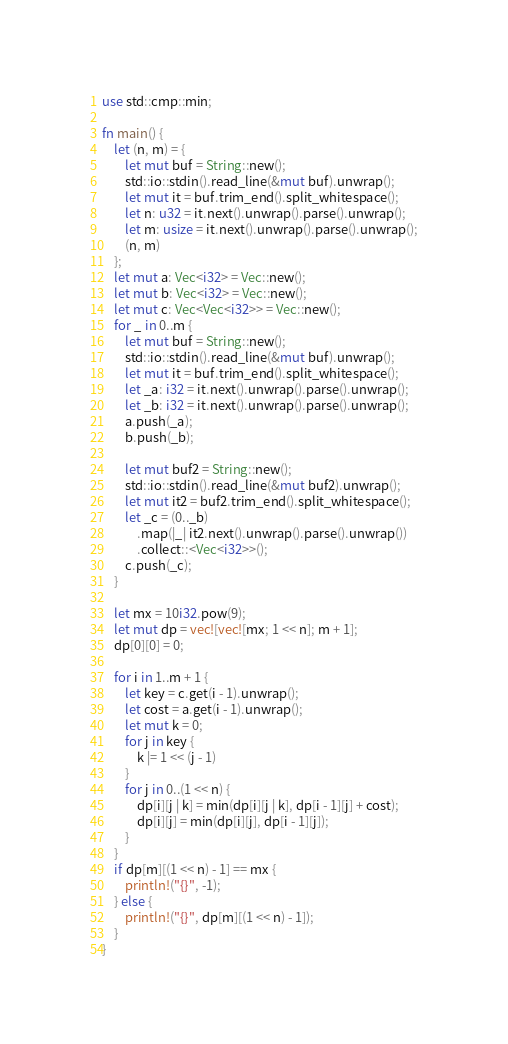Convert code to text. <code><loc_0><loc_0><loc_500><loc_500><_Rust_>use std::cmp::min;

fn main() {
    let (n, m) = {
        let mut buf = String::new();
        std::io::stdin().read_line(&mut buf).unwrap();
        let mut it = buf.trim_end().split_whitespace();
        let n: u32 = it.next().unwrap().parse().unwrap();
        let m: usize = it.next().unwrap().parse().unwrap();
        (n, m)
    };
    let mut a: Vec<i32> = Vec::new();
    let mut b: Vec<i32> = Vec::new();
    let mut c: Vec<Vec<i32>> = Vec::new();
    for _ in 0..m {
        let mut buf = String::new();
        std::io::stdin().read_line(&mut buf).unwrap();
        let mut it = buf.trim_end().split_whitespace();
        let _a: i32 = it.next().unwrap().parse().unwrap();
        let _b: i32 = it.next().unwrap().parse().unwrap();
        a.push(_a);
        b.push(_b);

        let mut buf2 = String::new();
        std::io::stdin().read_line(&mut buf2).unwrap();
        let mut it2 = buf2.trim_end().split_whitespace();
        let _c = (0.._b)
            .map(|_| it2.next().unwrap().parse().unwrap())
            .collect::<Vec<i32>>();
        c.push(_c);
    }

    let mx = 10i32.pow(9);
    let mut dp = vec![vec![mx; 1 << n]; m + 1];
    dp[0][0] = 0;

    for i in 1..m + 1 {
        let key = c.get(i - 1).unwrap();
        let cost = a.get(i - 1).unwrap();
        let mut k = 0;
        for j in key {
            k |= 1 << (j - 1)
        }
        for j in 0..(1 << n) {
            dp[i][j | k] = min(dp[i][j | k], dp[i - 1][j] + cost);
            dp[i][j] = min(dp[i][j], dp[i - 1][j]);
        }
    }
    if dp[m][(1 << n) - 1] == mx {
        println!("{}", -1);
    } else {
        println!("{}", dp[m][(1 << n) - 1]);
    }
}</code> 